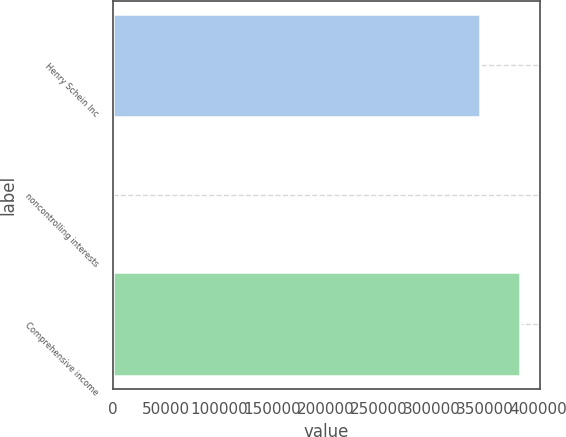<chart> <loc_0><loc_0><loc_500><loc_500><bar_chart><fcel>Henry Schein Inc<fcel>noncontrolling interests<fcel>Comprehensive income<nl><fcel>345626<fcel>29<fcel>382640<nl></chart> 